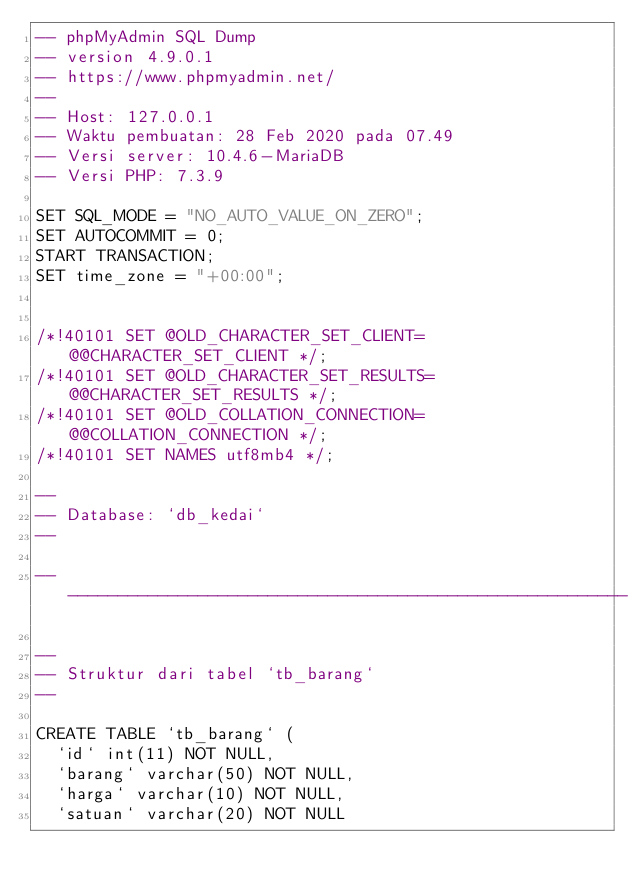Convert code to text. <code><loc_0><loc_0><loc_500><loc_500><_SQL_>-- phpMyAdmin SQL Dump
-- version 4.9.0.1
-- https://www.phpmyadmin.net/
--
-- Host: 127.0.0.1
-- Waktu pembuatan: 28 Feb 2020 pada 07.49
-- Versi server: 10.4.6-MariaDB
-- Versi PHP: 7.3.9

SET SQL_MODE = "NO_AUTO_VALUE_ON_ZERO";
SET AUTOCOMMIT = 0;
START TRANSACTION;
SET time_zone = "+00:00";


/*!40101 SET @OLD_CHARACTER_SET_CLIENT=@@CHARACTER_SET_CLIENT */;
/*!40101 SET @OLD_CHARACTER_SET_RESULTS=@@CHARACTER_SET_RESULTS */;
/*!40101 SET @OLD_COLLATION_CONNECTION=@@COLLATION_CONNECTION */;
/*!40101 SET NAMES utf8mb4 */;

--
-- Database: `db_kedai`
--

-- --------------------------------------------------------

--
-- Struktur dari tabel `tb_barang`
--

CREATE TABLE `tb_barang` (
  `id` int(11) NOT NULL,
  `barang` varchar(50) NOT NULL,
  `harga` varchar(10) NOT NULL,
  `satuan` varchar(20) NOT NULL</code> 